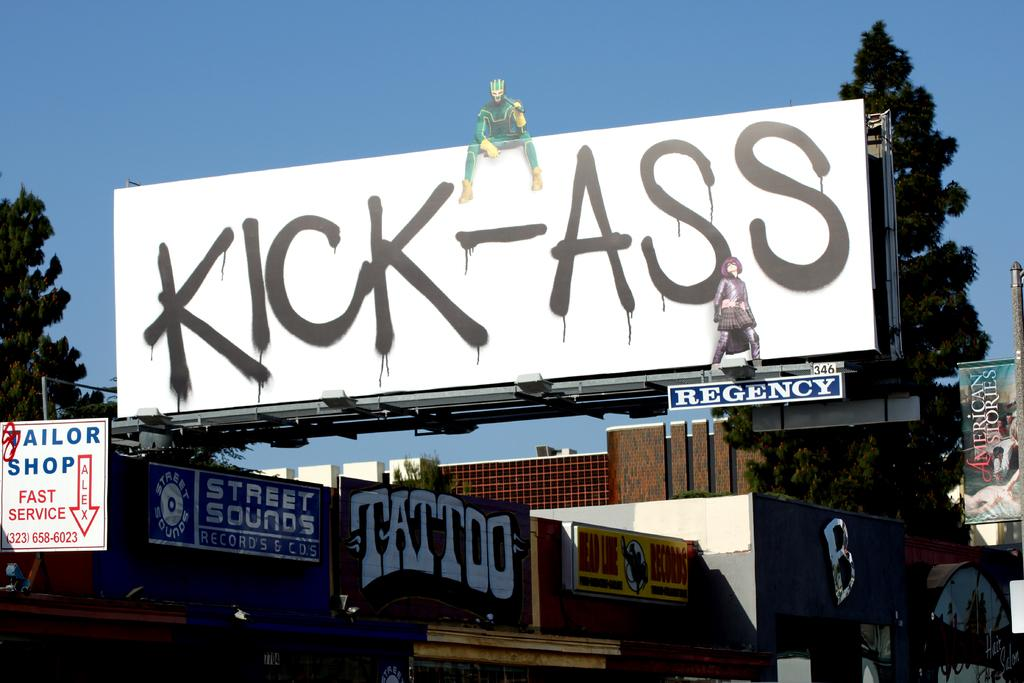<image>
Write a terse but informative summary of the picture. A sign for a tailor shop hags to the left of a larger sign. 